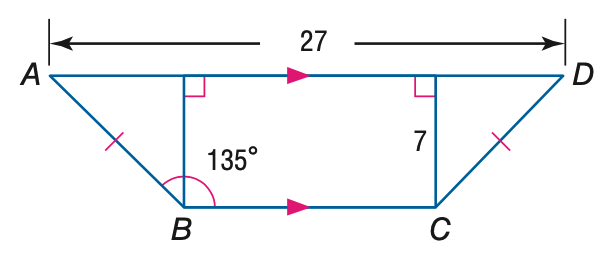Answer the mathemtical geometry problem and directly provide the correct option letter.
Question: Find the perimeter of quadrilateral A B C D.
Choices: A: 27 + 14 \sqrt { 2 } B: 40 + 14 \sqrt { 2 } C: 27 + 28 \sqrt { 2 } D: 40 + 28 \sqrt { 2 } B 